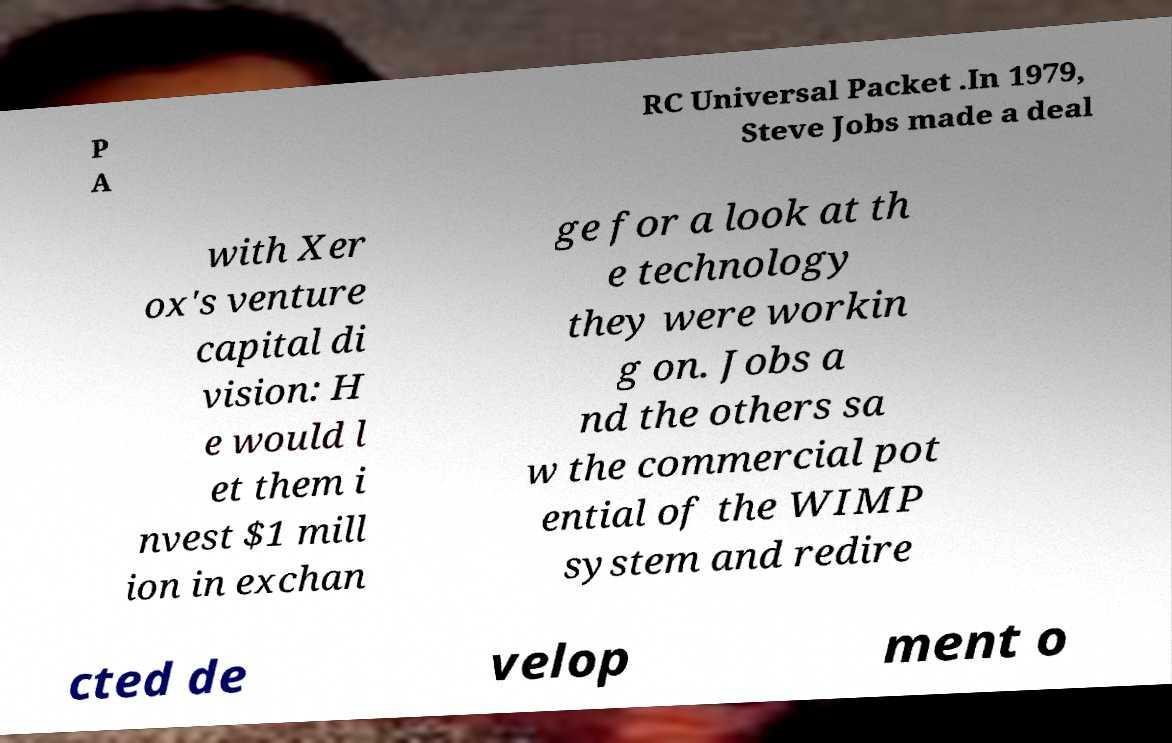There's text embedded in this image that I need extracted. Can you transcribe it verbatim? P A RC Universal Packet .In 1979, Steve Jobs made a deal with Xer ox's venture capital di vision: H e would l et them i nvest $1 mill ion in exchan ge for a look at th e technology they were workin g on. Jobs a nd the others sa w the commercial pot ential of the WIMP system and redire cted de velop ment o 